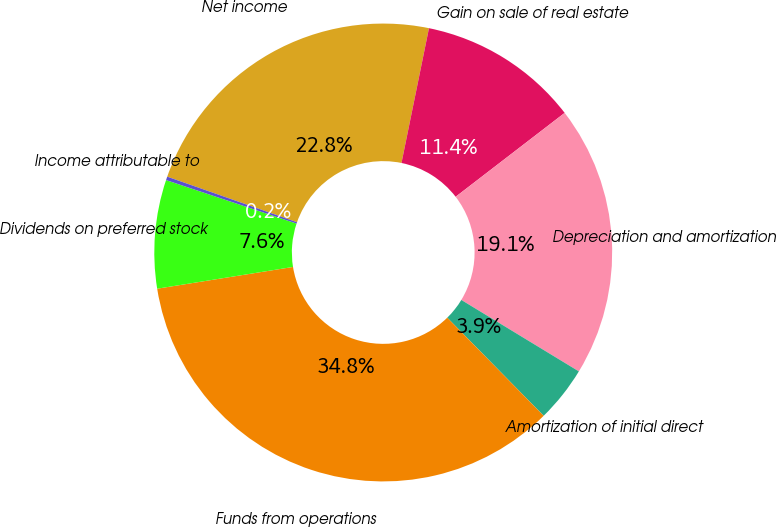<chart> <loc_0><loc_0><loc_500><loc_500><pie_chart><fcel>Net income<fcel>Gain on sale of real estate<fcel>Depreciation and amortization<fcel>Amortization of initial direct<fcel>Funds from operations<fcel>Dividends on preferred stock<fcel>Income attributable to<nl><fcel>22.83%<fcel>11.36%<fcel>19.13%<fcel>3.95%<fcel>34.83%<fcel>7.65%<fcel>0.25%<nl></chart> 